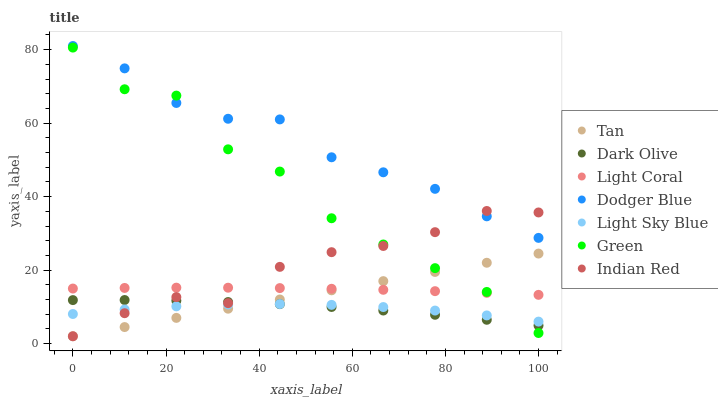Does Light Sky Blue have the minimum area under the curve?
Answer yes or no. Yes. Does Dodger Blue have the maximum area under the curve?
Answer yes or no. Yes. Does Light Coral have the minimum area under the curve?
Answer yes or no. No. Does Light Coral have the maximum area under the curve?
Answer yes or no. No. Is Tan the smoothest?
Answer yes or no. Yes. Is Green the roughest?
Answer yes or no. Yes. Is Light Coral the smoothest?
Answer yes or no. No. Is Light Coral the roughest?
Answer yes or no. No. Does Indian Red have the lowest value?
Answer yes or no. Yes. Does Light Coral have the lowest value?
Answer yes or no. No. Does Dodger Blue have the highest value?
Answer yes or no. Yes. Does Light Coral have the highest value?
Answer yes or no. No. Is Light Sky Blue less than Light Coral?
Answer yes or no. Yes. Is Light Coral greater than Dark Olive?
Answer yes or no. Yes. Does Green intersect Dark Olive?
Answer yes or no. Yes. Is Green less than Dark Olive?
Answer yes or no. No. Is Green greater than Dark Olive?
Answer yes or no. No. Does Light Sky Blue intersect Light Coral?
Answer yes or no. No. 